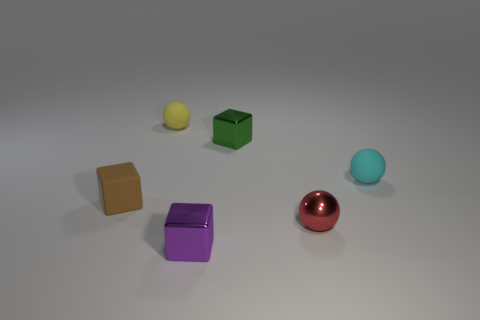Are there any spheres of the same color as the small matte block?
Ensure brevity in your answer.  No. The metallic block that is the same size as the purple object is what color?
Offer a very short reply. Green. Is there a small red sphere behind the tiny shiny block behind the cyan rubber thing?
Keep it short and to the point. No. There is a tiny cube that is behind the small cyan matte object; what material is it?
Provide a short and direct response. Metal. Do the tiny sphere that is right of the red object and the ball in front of the cyan matte sphere have the same material?
Provide a short and direct response. No. Are there an equal number of green metallic things to the left of the tiny rubber block and small balls on the left side of the metallic sphere?
Give a very brief answer. No. How many other small cyan objects have the same material as the cyan object?
Offer a very short reply. 0. There is a rubber object that is to the right of the tiny ball that is to the left of the tiny red sphere; what is its size?
Give a very brief answer. Small. There is a shiny thing to the left of the green thing; does it have the same shape as the small rubber thing right of the tiny yellow thing?
Your answer should be very brief. No. Is the number of small yellow things that are to the right of the yellow rubber sphere the same as the number of purple metallic blocks?
Your answer should be very brief. No. 